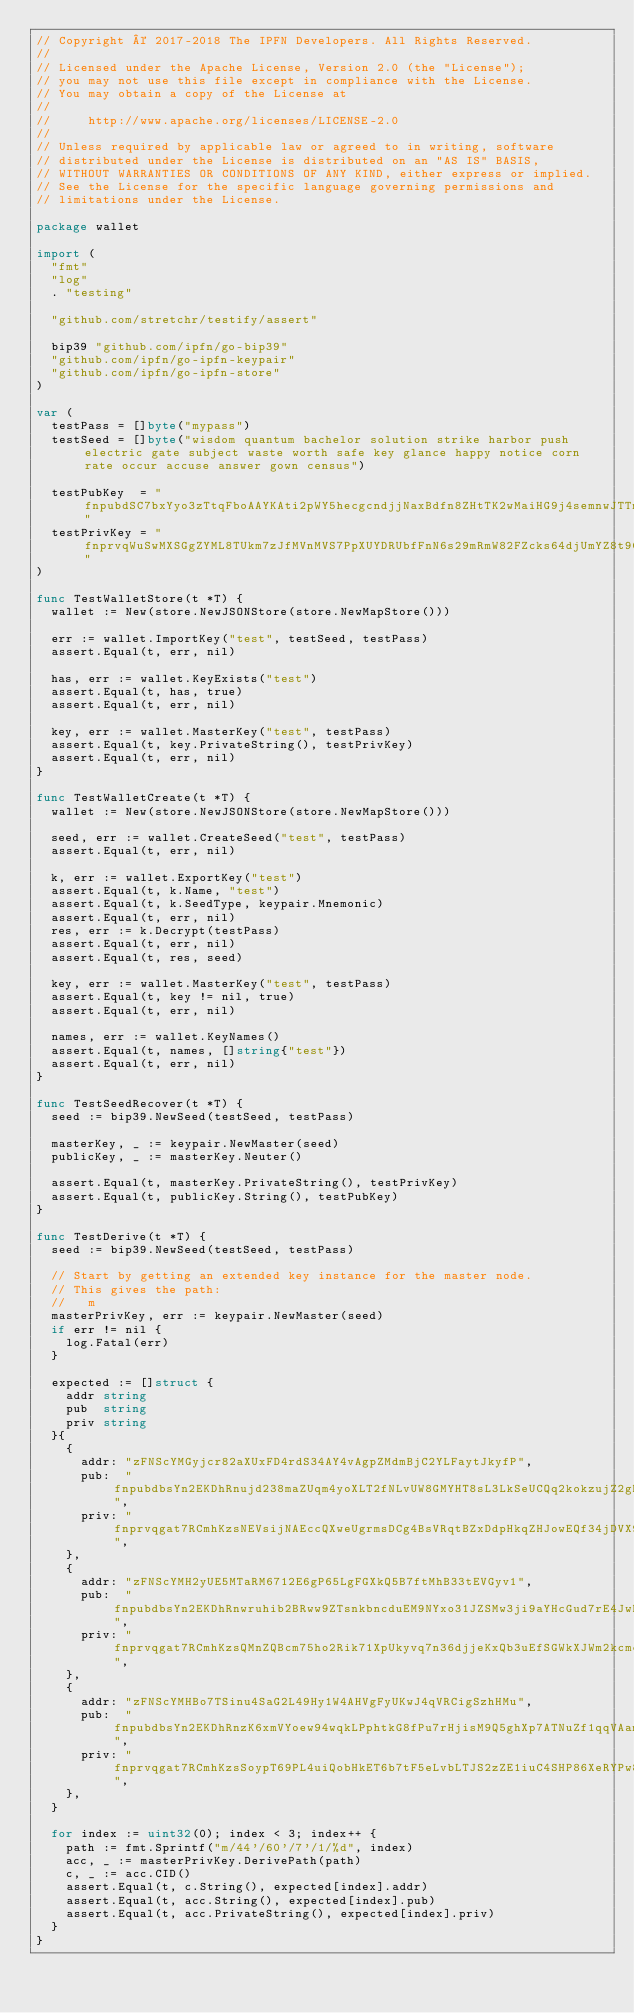Convert code to text. <code><loc_0><loc_0><loc_500><loc_500><_Go_>// Copyright © 2017-2018 The IPFN Developers. All Rights Reserved.
//
// Licensed under the Apache License, Version 2.0 (the "License");
// you may not use this file except in compliance with the License.
// You may obtain a copy of the License at
//
//     http://www.apache.org/licenses/LICENSE-2.0
//
// Unless required by applicable law or agreed to in writing, software
// distributed under the License is distributed on an "AS IS" BASIS,
// WITHOUT WARRANTIES OR CONDITIONS OF ANY KIND, either express or implied.
// See the License for the specific language governing permissions and
// limitations under the License.

package wallet

import (
	"fmt"
	"log"
	. "testing"

	"github.com/stretchr/testify/assert"

	bip39 "github.com/ipfn/go-bip39"
	"github.com/ipfn/go-ipfn-keypair"
	"github.com/ipfn/go-ipfn-store"
)

var (
	testPass = []byte("mypass")
	testSeed = []byte("wisdom quantum bachelor solution strike harbor push electric gate subject waste worth safe key glance happy notice corn rate occur accuse answer gown census")

	testPubKey  = "fnpubdSC7bxYyo3zTtqFboAAYKAti2pWY5hecgcndjjNaxBdfn8ZHtTK2wMaiHG9j4semnwJTTmGvBm9TToMeY5t9bHYT9gz2MzrzHxynANGWWk1"
	testPrivKey = "fnprvqWuSwMXSGgZYML8TUkm7zJfMVnMVS7PpXUYDRUbfFnN6s29mRmW82FZcks64djUmYZ8t9CLaxc4dFAMvxxdiKGn9iqjp783LLv9c45Z9HpR"
)

func TestWalletStore(t *T) {
	wallet := New(store.NewJSONStore(store.NewMapStore()))

	err := wallet.ImportKey("test", testSeed, testPass)
	assert.Equal(t, err, nil)

	has, err := wallet.KeyExists("test")
	assert.Equal(t, has, true)
	assert.Equal(t, err, nil)

	key, err := wallet.MasterKey("test", testPass)
	assert.Equal(t, key.PrivateString(), testPrivKey)
	assert.Equal(t, err, nil)
}

func TestWalletCreate(t *T) {
	wallet := New(store.NewJSONStore(store.NewMapStore()))

	seed, err := wallet.CreateSeed("test", testPass)
	assert.Equal(t, err, nil)

	k, err := wallet.ExportKey("test")
	assert.Equal(t, k.Name, "test")
	assert.Equal(t, k.SeedType, keypair.Mnemonic)
	assert.Equal(t, err, nil)
	res, err := k.Decrypt(testPass)
	assert.Equal(t, err, nil)
	assert.Equal(t, res, seed)

	key, err := wallet.MasterKey("test", testPass)
	assert.Equal(t, key != nil, true)
	assert.Equal(t, err, nil)

	names, err := wallet.KeyNames()
	assert.Equal(t, names, []string{"test"})
	assert.Equal(t, err, nil)
}

func TestSeedRecover(t *T) {
	seed := bip39.NewSeed(testSeed, testPass)

	masterKey, _ := keypair.NewMaster(seed)
	publicKey, _ := masterKey.Neuter()

	assert.Equal(t, masterKey.PrivateString(), testPrivKey)
	assert.Equal(t, publicKey.String(), testPubKey)
}

func TestDerive(t *T) {
	seed := bip39.NewSeed(testSeed, testPass)

	// Start by getting an extended key instance for the master node.
	// This gives the path:
	//   m
	masterPrivKey, err := keypair.NewMaster(seed)
	if err != nil {
		log.Fatal(err)
	}

	expected := []struct {
		addr string
		pub  string
		priv string
	}{
		{
			addr: "zFNScYMGyjcr82aXUxFD4rdS34AY4vAgpZMdmBjC2YLFaytJkyfP",
			pub:  "fnpubdbsYn2EKDhRnujd238maZUqm4yoXLT2fNLvUW8GMYHT8sL3LkSeUCQq2kokzujZ2gDGjBHNMKyY5WvzKdt3yseZXwpYwnTMLMRuSJwobbcc",
			priv: "fnprvqgat7RCmhKzsNEVsijNAEccQXweUgrmsDCg4BsVRqtBZxDdpHkqZHJowEQf34jDVX99cieC6gvzRthk7euuKXNZ9qmjUajp16XtHk4x7BTo",
		},
		{
			addr: "zFNScYMH2yUE5MTaRM6712E6gP65LgFGXkQ5B7ftMhB33tEVGyv1",
			pub:  "fnpubdbsYn2EKDhRnwruhib2BRww9ZTsnkbncduEM9NYxo31JZSMw3ji9aYHcGud7rE4JwBqi27gP7xHDdF98Lnz9tYqDoLFjsYSe8DvjcwwLBeF",
			priv: "fnprvqgat7RCmhKzsQMnZQBcm75ho2Rik71XpUkyvq7n36djjeKxQb3uEfSGWkXJWm2kcmcapqoyVU6xn5N1C6oZKYJsPWkvhJemYCq4KfMXCcjc",
		},
		{
			addr: "zFNScYMHBo7TSinu4SaG2L49Hy1W4AHVgFyUKwJ4qVRCigSzhHMu",
			pub:  "fnpubdbsYn2EKDhRnzK6xmVYoew94wqkLPphtkG8fPu7rHjisM9Q5ghXp7ATNuZf1qqVAamh3YuKWKpDkgoSsCjxxf2QNUDg1Th8HtE1zxMbCwCT",
			priv: "fnprvqgat7RCmhKzsSoypT69PL4uiQobHkET6b7tF5eLvbLTJS2zZE1iuC4SHP86XeRYPw8SqgqimBNYZj1VHZy2kCEKyCo5S44QivATiPRwruha",
		},
	}

	for index := uint32(0); index < 3; index++ {
		path := fmt.Sprintf("m/44'/60'/7'/1/%d", index)
		acc, _ := masterPrivKey.DerivePath(path)
		c, _ := acc.CID()
		assert.Equal(t, c.String(), expected[index].addr)
		assert.Equal(t, acc.String(), expected[index].pub)
		assert.Equal(t, acc.PrivateString(), expected[index].priv)
	}
}
</code> 